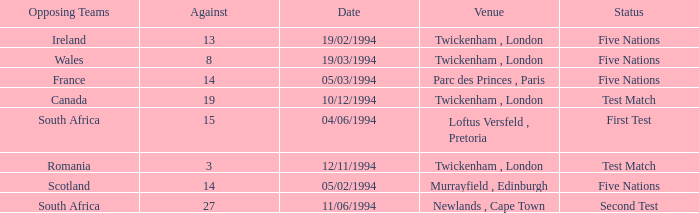Give me the full table as a dictionary. {'header': ['Opposing Teams', 'Against', 'Date', 'Venue', 'Status'], 'rows': [['Ireland', '13', '19/02/1994', 'Twickenham , London', 'Five Nations'], ['Wales', '8', '19/03/1994', 'Twickenham , London', 'Five Nations'], ['France', '14', '05/03/1994', 'Parc des Princes , Paris', 'Five Nations'], ['Canada', '19', '10/12/1994', 'Twickenham , London', 'Test Match'], ['South Africa', '15', '04/06/1994', 'Loftus Versfeld , Pretoria', 'First Test'], ['Romania', '3', '12/11/1994', 'Twickenham , London', 'Test Match'], ['Scotland', '14', '05/02/1994', 'Murrayfield , Edinburgh', 'Five Nations'], ['South Africa', '27', '11/06/1994', 'Newlands , Cape Town', 'Second Test']]} How many against have a status of first test? 1.0. 